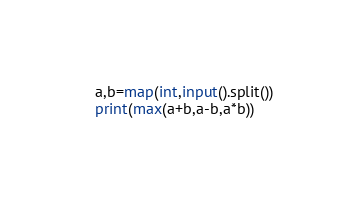<code> <loc_0><loc_0><loc_500><loc_500><_Python_>a,b=map(int,input().split())
print(max(a+b,a-b,a*b))</code> 